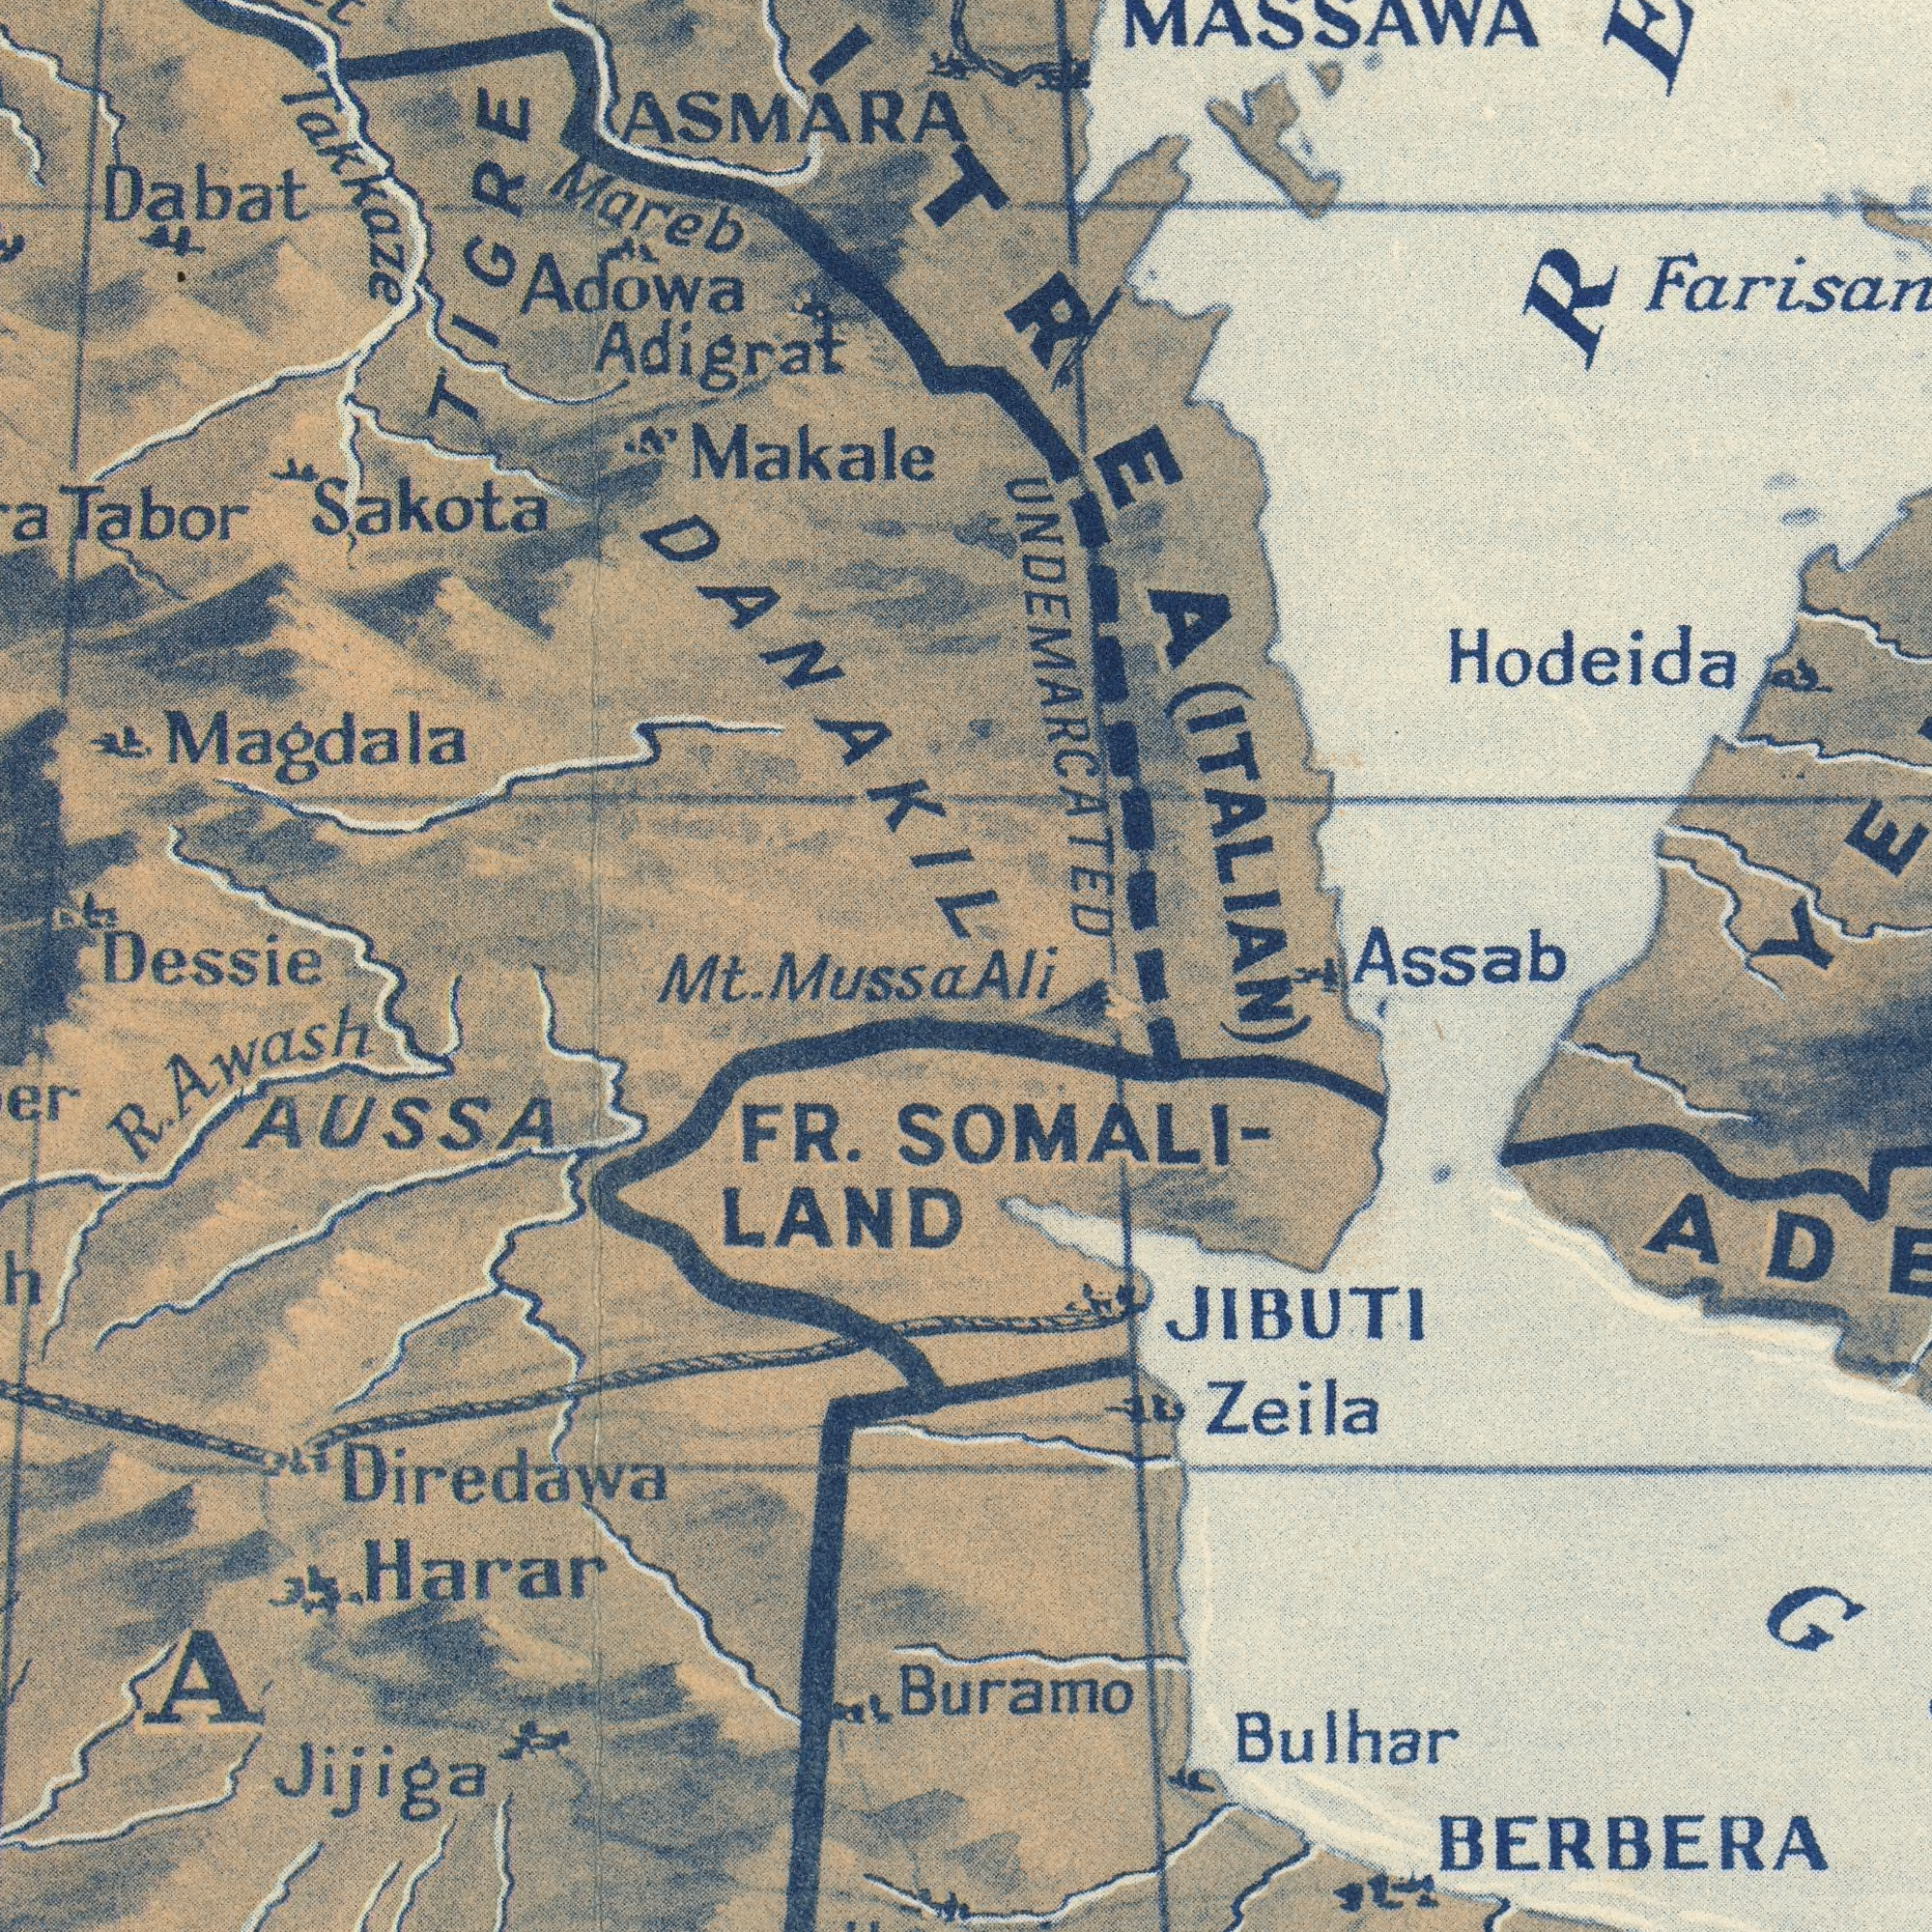What text is visible in the lower-right corner? SOMALI- Bulhar Zeila JIBUTI Buramo BERBERA Ali Assab What text is visible in the upper-right corner? Hodeida MASSAWA UNDEMARCATED ###ITREA (ITALIAN) What text is visible in the upper-left corner? Mareb Makale Dabat Adowa Tabor ASMARA Sakota Adigrat Magdala DANAKIL Takkaze TIGRE What text can you see in the bottom-left section? FR. LAND Diredawa AUSSA Harar R. Awash ###A Jijiga Mt. Mussa Dessie 